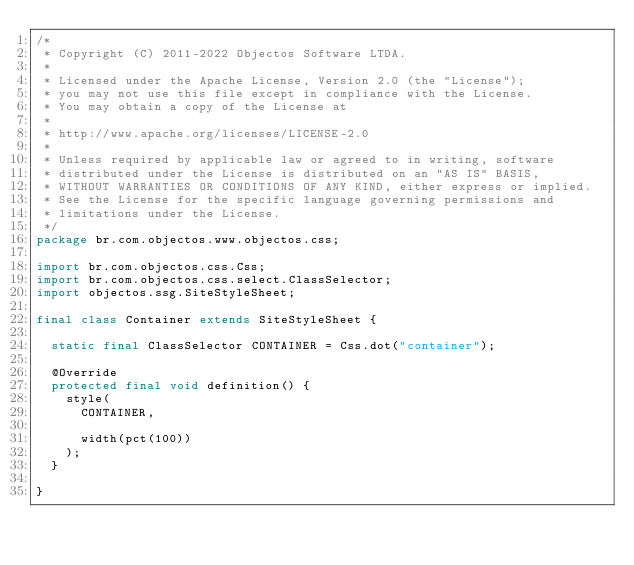<code> <loc_0><loc_0><loc_500><loc_500><_Java_>/*
 * Copyright (C) 2011-2022 Objectos Software LTDA.
 *
 * Licensed under the Apache License, Version 2.0 (the "License");
 * you may not use this file except in compliance with the License.
 * You may obtain a copy of the License at
 *
 * http://www.apache.org/licenses/LICENSE-2.0
 *
 * Unless required by applicable law or agreed to in writing, software
 * distributed under the License is distributed on an "AS IS" BASIS,
 * WITHOUT WARRANTIES OR CONDITIONS OF ANY KIND, either express or implied.
 * See the License for the specific language governing permissions and
 * limitations under the License.
 */
package br.com.objectos.www.objectos.css;

import br.com.objectos.css.Css;
import br.com.objectos.css.select.ClassSelector;
import objectos.ssg.SiteStyleSheet;

final class Container extends SiteStyleSheet {

  static final ClassSelector CONTAINER = Css.dot("container");

  @Override
  protected final void definition() {
    style(
      CONTAINER,

      width(pct(100))
    );
  }

}</code> 